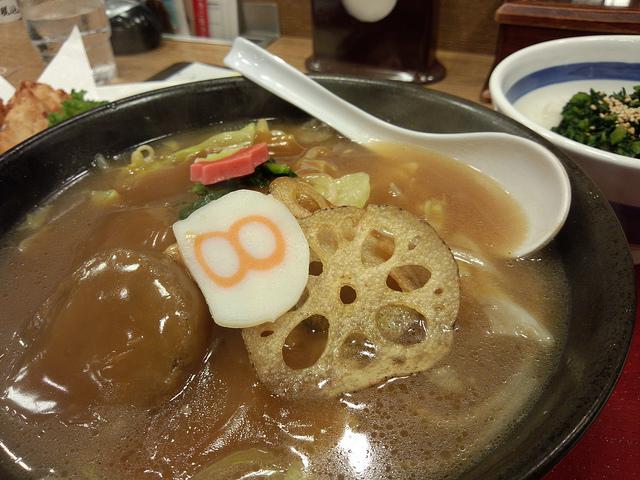Is the food tasty?
Quick response, please. No. What color is the spoon?
Give a very brief answer. White. What food is in the picture?
Keep it brief. Soup. Is the food delicious?
Write a very short answer. Yes. What nationality is this cuisine?
Short answer required. Mexican. Is there a utensil in the pot?
Quick response, please. Yes. Where is the glass of water?
Keep it brief. Table. 